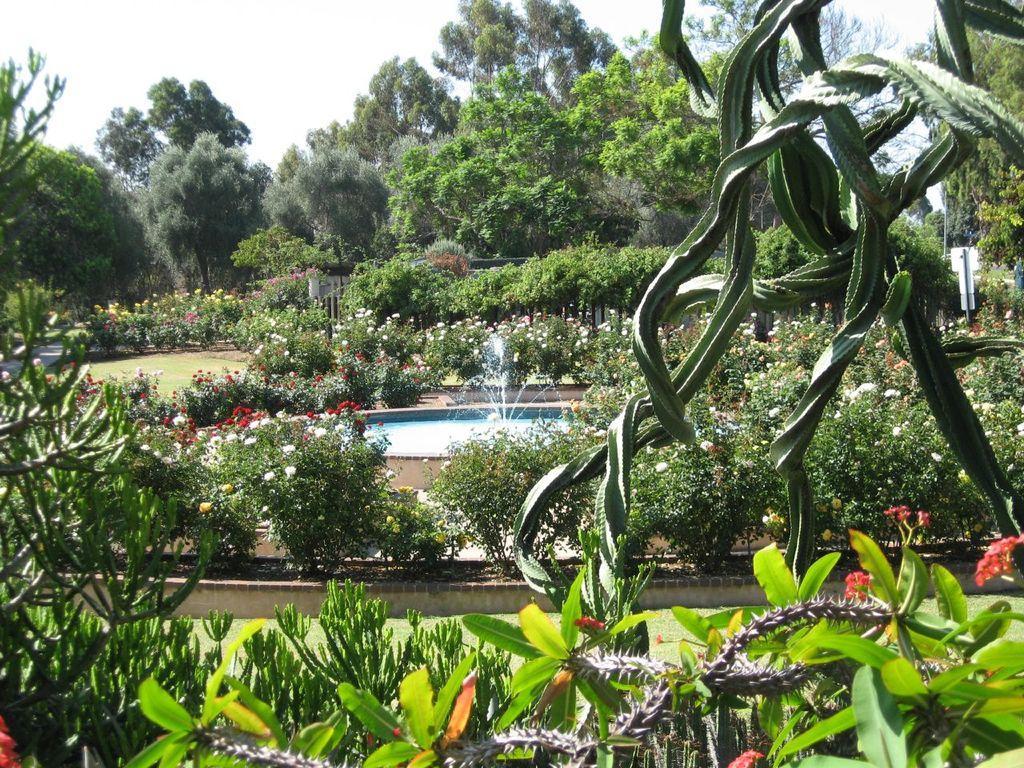Describe this image in one or two sentences. In this image I see number of plants on which there are flowers which are colorful and I see the fountain over here and in the background I see number of trees and the sky. 